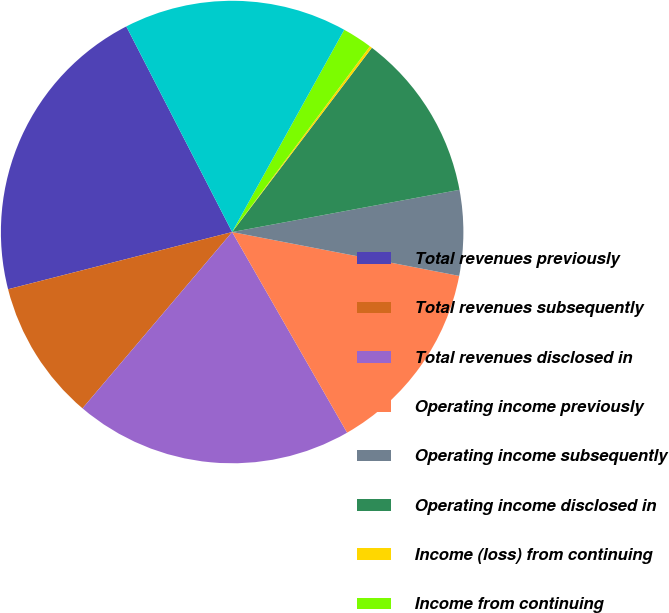Convert chart to OTSL. <chart><loc_0><loc_0><loc_500><loc_500><pie_chart><fcel>Total revenues previously<fcel>Total revenues subsequently<fcel>Total revenues disclosed in<fcel>Operating income previously<fcel>Operating income subsequently<fcel>Operating income disclosed in<fcel>Income (loss) from continuing<fcel>Income from continuing<fcel>Discontinued operations net<nl><fcel>21.41%<fcel>9.82%<fcel>19.48%<fcel>13.68%<fcel>5.96%<fcel>11.75%<fcel>0.17%<fcel>2.1%<fcel>15.62%<nl></chart> 